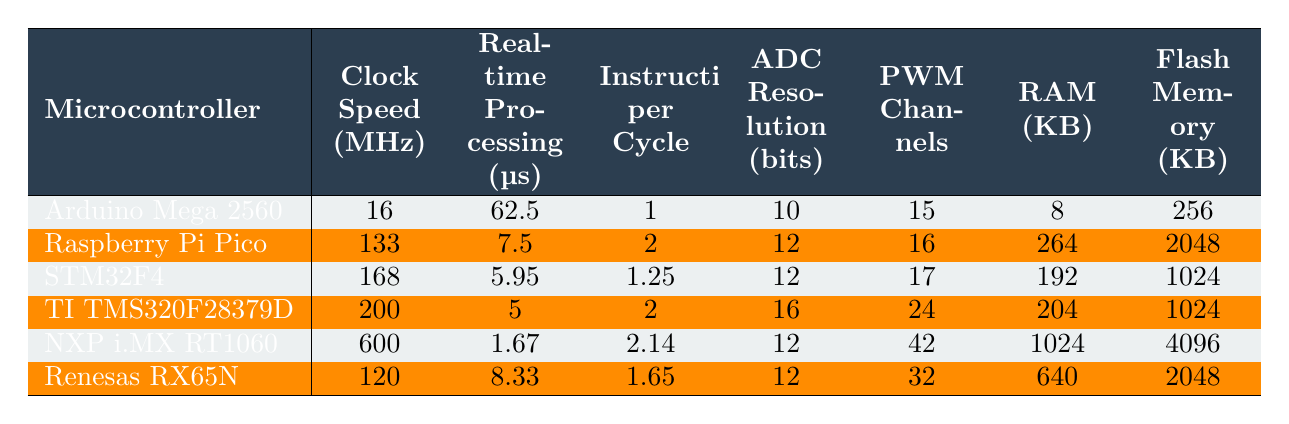What is the clock speed of the STM32F4 microcontroller? The table lists the clock speed of the STM32F4 microcontroller as 168 MHz.
Answer: 168 MHz Which microcontroller has the highest real-time processing speed? The microcontroller with the highest real-time processing speed is the Texas Instruments TMS320F28379D, with a processing time of 5 µs.
Answer: Texas Instruments TMS320F28379D What is the average RAM (in KB) of all the microcontrollers listed? The RAM values are 8, 264, 192, 204, 1024, and 640. The sum is 8 + 264 + 192 + 204 + 1024 + 640 = 2332. There are 6 microcontrollers, so the average is 2332 / 6 ≈ 388.67.
Answer: 388.67 KB Does the NXP i.MX RT1060 have a higher PWM channel count than the Arduino Mega 2560? The NXP i.MX RT1060 has 42 PWM channels, while the Arduino Mega 2560 has 15. Since 42 is greater than 15, the statement is true.
Answer: Yes Which microcontroller has the lowest ADC resolution and what is that value? The microcontroller with the lowest ADC resolution is the Arduino Mega 2560, with a resolution of 10 bits.
Answer: 10 bits If you were to sort the microcontrollers by real-time processing speed in ascending order, which would be the first two? The first two microcontrollers when sorted by real-time processing speed in ascending order are the NXP i.MX RT1060 (1.67 µs) and Texas Instruments TMS320F28379D (5 µs).
Answer: NXP i.MX RT1060 and Texas Instruments TMS320F28379D How many microcontrollers have a flash memory capacity greater than 1 KB? The microcontrollers with flash memory greater than 1 KB are the Raspberry Pi Pico (2048 KB), STM32F4 (1024 KB), NXP i.MX RT1060 (4096 KB), and Renesas RX65N (2048 KB). That totals 4 microcontrollers.
Answer: 4 What is the difference in real-time processing time between the fastest and the slowest microcontrollers? The fastest is the NXP i.MX RT1060 at 1.67 µs and the slowest is the Arduino Mega 2560 at 62.5 µs. The difference is 62.5 - 1.67 = 60.83 µs.
Answer: 60.83 µs Is the Raspberry Pi Pico's clock speed more than twice that of the Arduino Mega 2560? The clock speed of the Raspberry Pi Pico is 133 MHz and that of the Arduino Mega 2560 is 16 MHz. Twice the Arduino's clock speed is 32 MHz. Since 133 MHz is greater than 32 MHz, the answer is yes.
Answer: Yes 